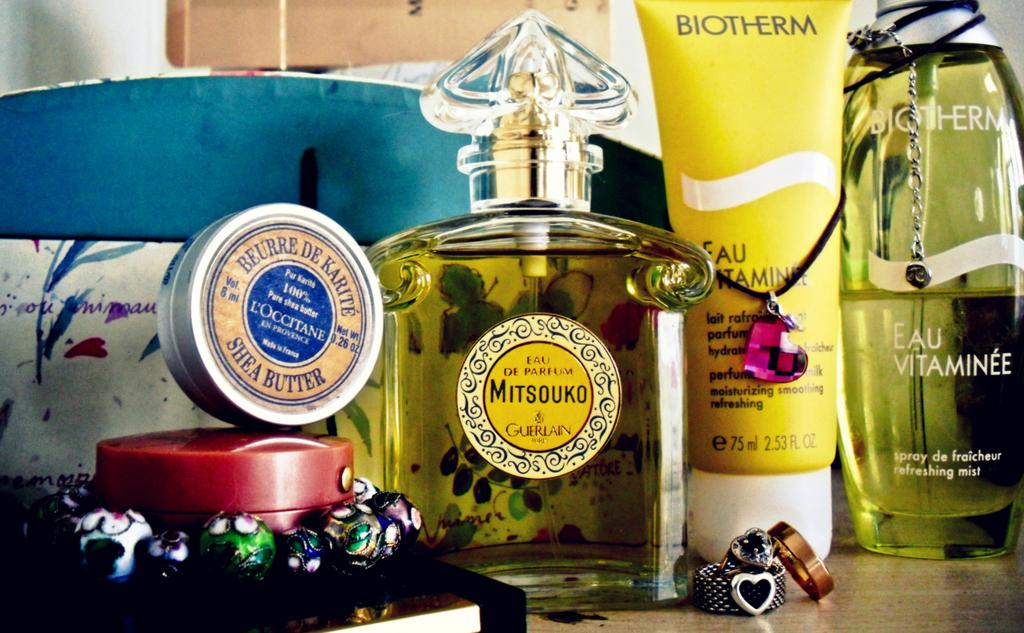<image>
Share a concise interpretation of the image provided. A couple of fragrance bottles including one by Mitsouko. 